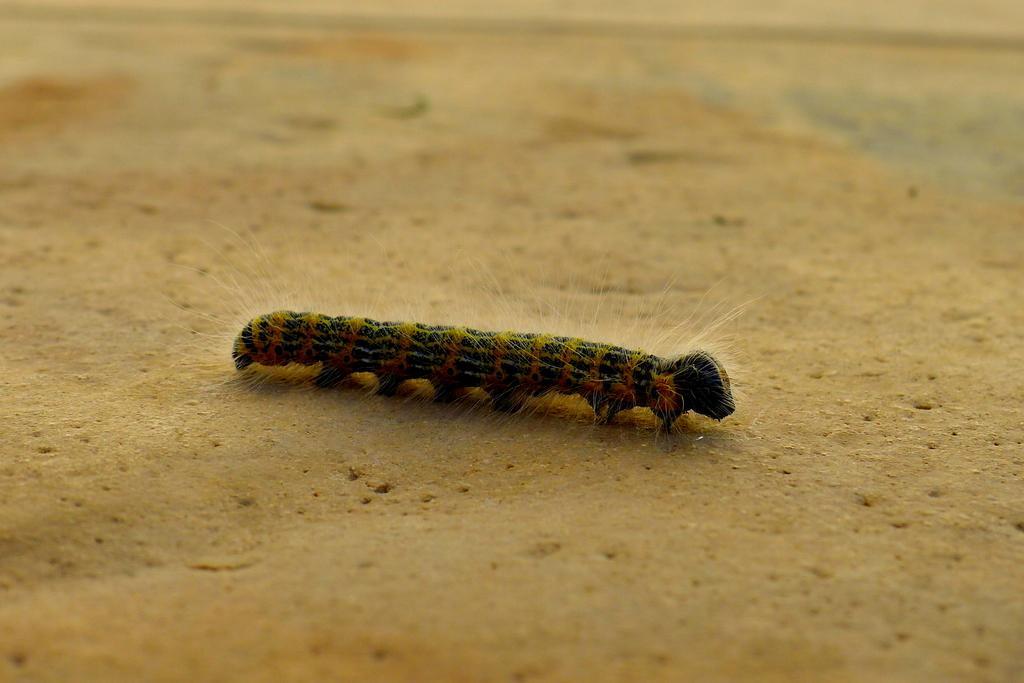Could you give a brief overview of what you see in this image? In the center of this picture we can see an insect seems to be a caterpillar on the ground. 